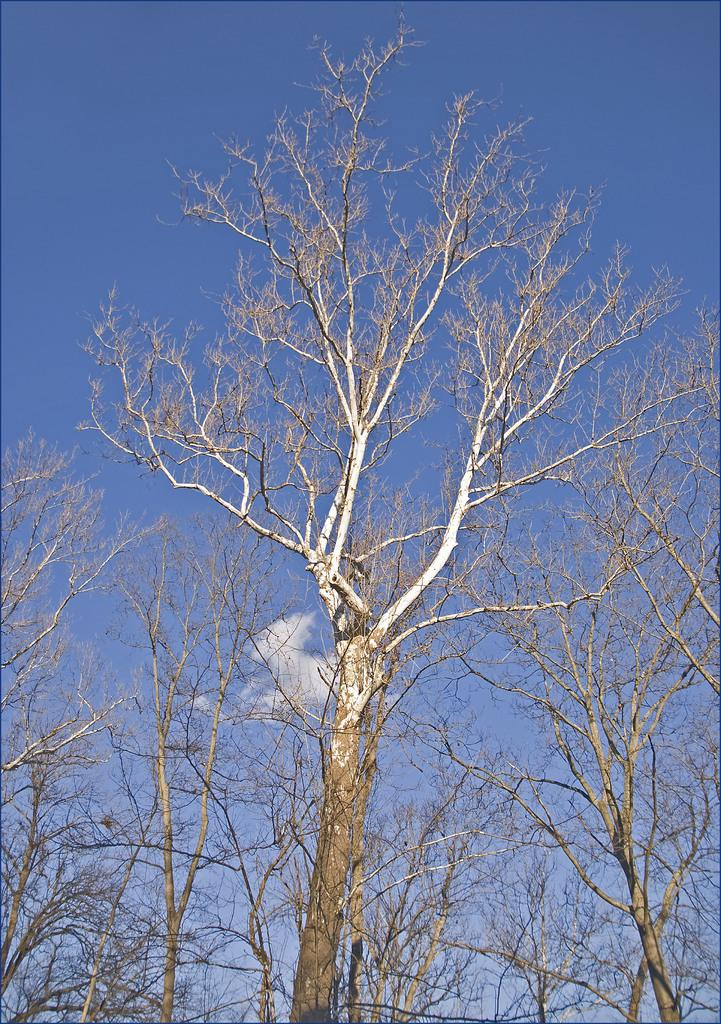What type of vegetation can be seen in the image? There are trees in the image. What can be seen in the sky in the image? There are clouds in the image. How many ladybugs are crawling on the trees in the image? There are no ladybugs present in the image; it only features trees and clouds. What type of power source is visible in the image? There is no power source visible in the image; it only features trees and clouds. 